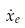Convert formula to latex. <formula><loc_0><loc_0><loc_500><loc_500>\dot { x } _ { e }</formula> 